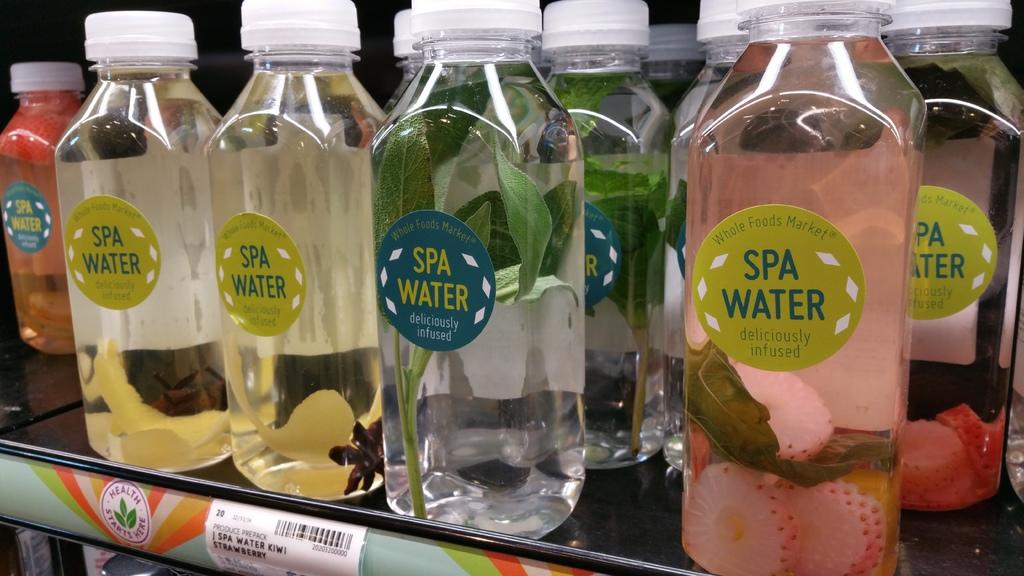Where is this spa water sold?
Your answer should be compact. Whole foods market. What makes the spa water different?
Ensure brevity in your answer.  Deliciously infused. 